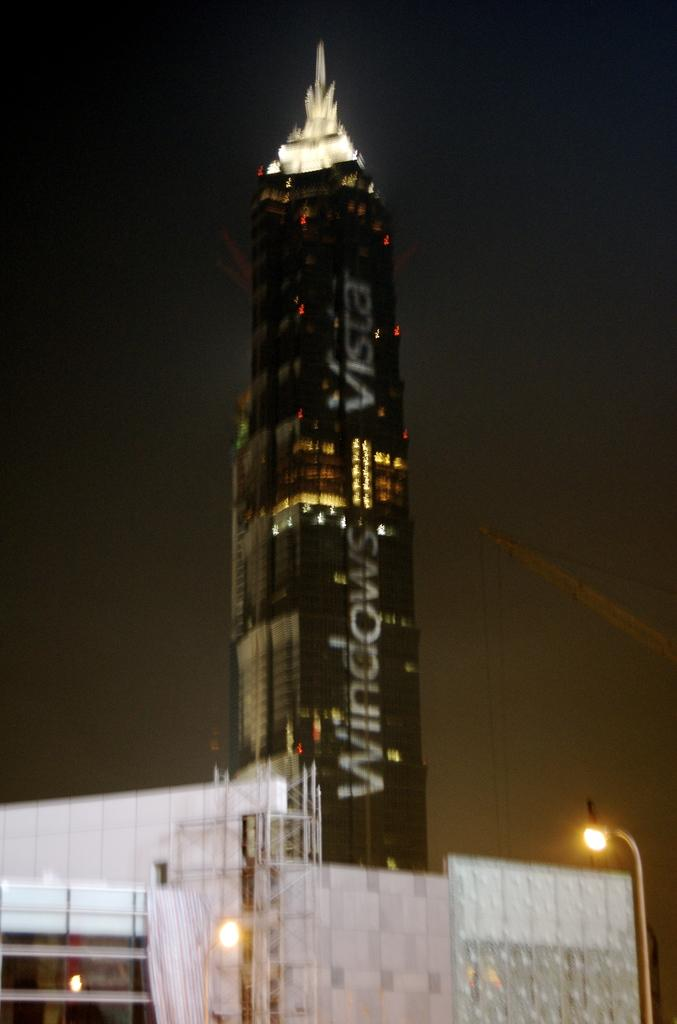What type of structures can be seen in the image? There are buildings in the image. What type of lighting is present in the image? Street lights are present in the image. What is the main feature in the middle of the image? There is a tower in the middle of the image. What can be seen in the background of the image? The sky is visible in the background of the image. How many tickets are hanging from the cord in the image? There is no mention of tickets or a cord in the image; it features buildings, street lights, a tower, and the sky. 